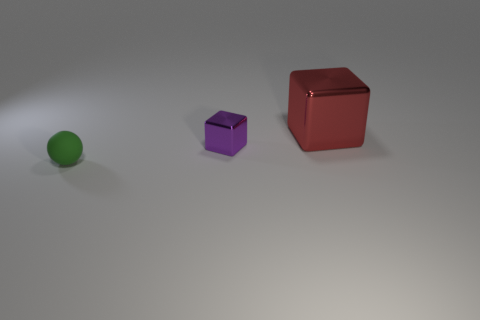Add 1 small brown balls. How many objects exist? 4 Subtract all purple cubes. How many cubes are left? 1 Subtract all balls. How many objects are left? 2 Add 2 purple metallic cubes. How many purple metallic cubes are left? 3 Add 3 small blocks. How many small blocks exist? 4 Subtract 0 gray blocks. How many objects are left? 3 Subtract all red cubes. Subtract all gray spheres. How many cubes are left? 1 Subtract all green shiny things. Subtract all red metallic things. How many objects are left? 2 